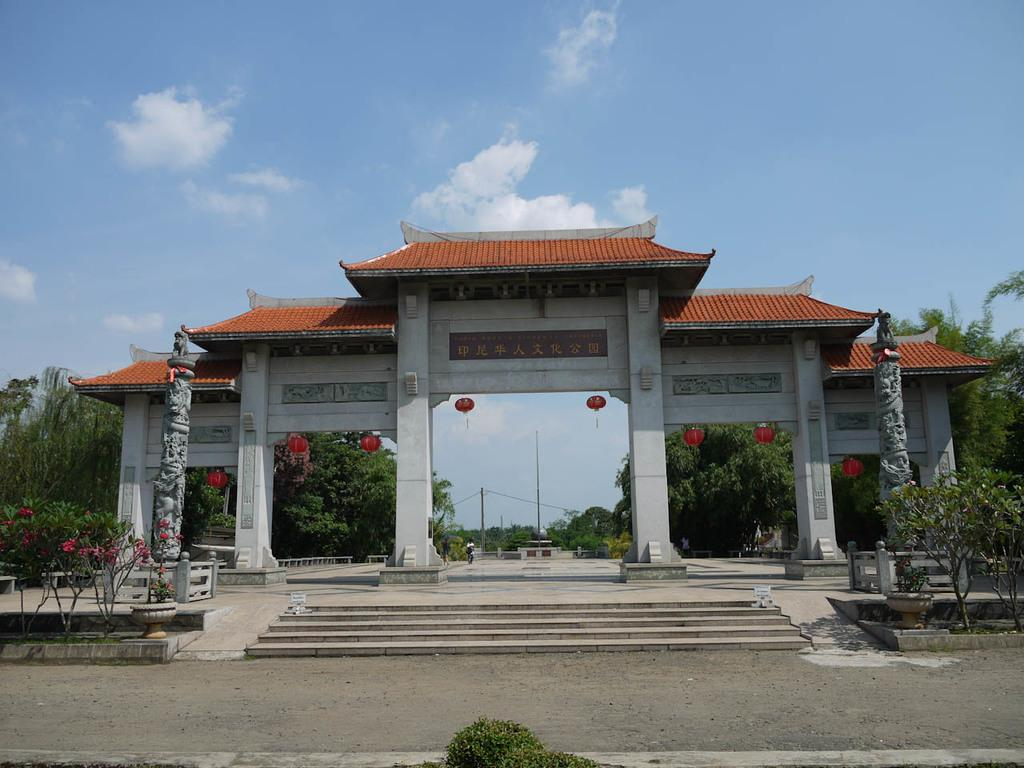What type of pathway is visible in the image? There is a road in the image. What architectural feature can be seen in the image? There are steps and pillars in the image. What type of lighting is present in the image? There are lanterns in the image. What type of vegetation is visible in the image? There are trees in the image. What other structures are present in the image? There are poles in the image. What can be seen in the background of the image? The sky is visible in the background of the image, and clouds are present in the sky. Can you tell me how many toy ships are floating in the water in the image? There is no water or toy ships present in the image. What type of sugar is being used to sweeten the trees in the image? There is no sugar or indication of sweetening the trees in the image. 